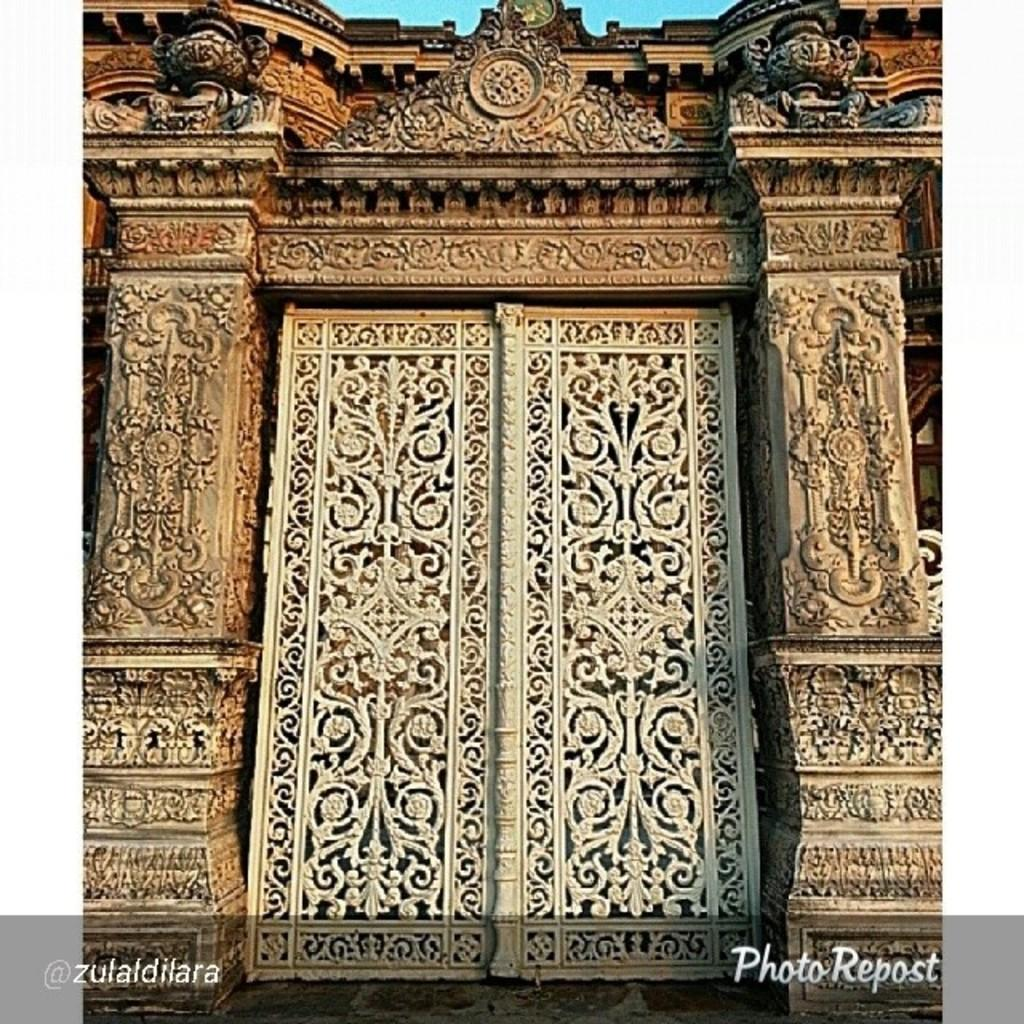What type of architectural feature can be seen in the image? There is a carved pillar in the image. What other carved feature is present in the image? There is a carved door in the image. Can you describe the level of detail in the carvings? The facts provided do not mention the level of detail in the carvings. What caused the feast to be held in the image? There is no mention of a feast or any cause for a feast in the image. How does the throat of the person in the image look? There is no person or throat visible in the image. 